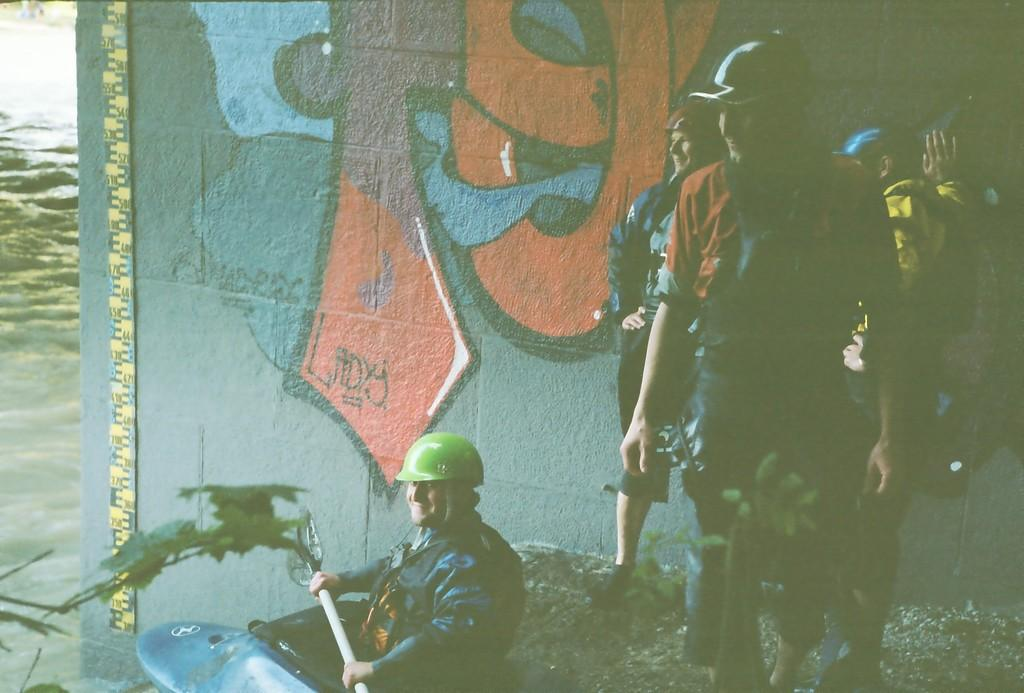What are the people in the image doing? The people in the image are standing on the mud beside the river. What is the man in the image doing? The man is sitting in a boat. What can be seen behind the people in the image? There is a wall with graffiti behind the people. Are there any bears visible in the image? No, there are no bears present in the image. What type of watch is the man wearing in the image? There is no watch visible on the man in the image. 